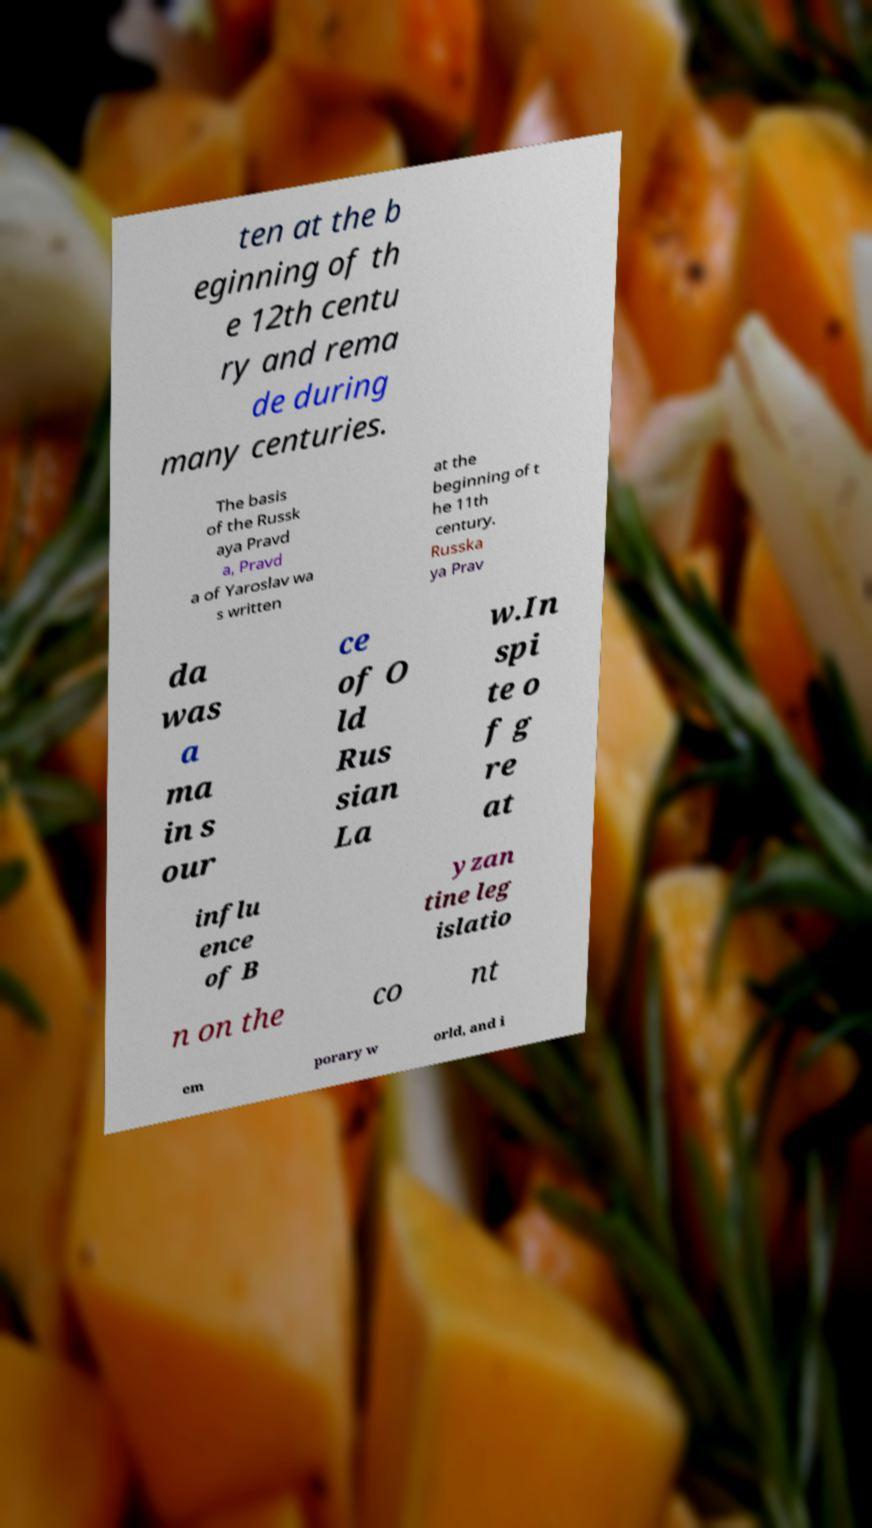Can you read and provide the text displayed in the image?This photo seems to have some interesting text. Can you extract and type it out for me? ten at the b eginning of th e 12th centu ry and rema de during many centuries. The basis of the Russk aya Pravd a, Pravd a of Yaroslav wa s written at the beginning of t he 11th century. Russka ya Prav da was a ma in s our ce of O ld Rus sian La w.In spi te o f g re at influ ence of B yzan tine leg islatio n on the co nt em porary w orld, and i 